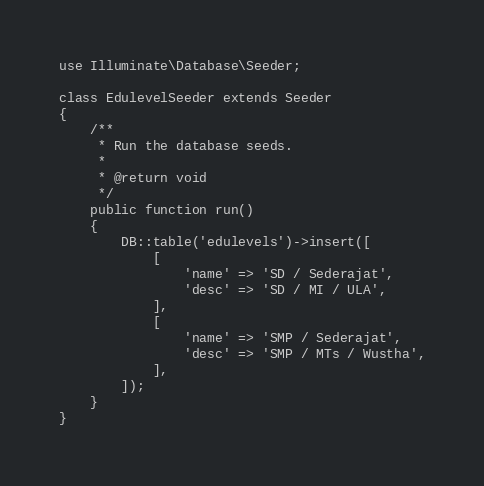<code> <loc_0><loc_0><loc_500><loc_500><_PHP_>
use Illuminate\Database\Seeder;

class EdulevelSeeder extends Seeder
{
    /**
     * Run the database seeds.
     *
     * @return void
     */
    public function run()
    {
        DB::table('edulevels')->insert([
            [
                'name' => 'SD / Sederajat',
                'desc' => 'SD / MI / ULA',
            ],
            [
                'name' => 'SMP / Sederajat',
                'desc' => 'SMP / MTs / Wustha',
            ],
        ]);
    }
}
</code> 